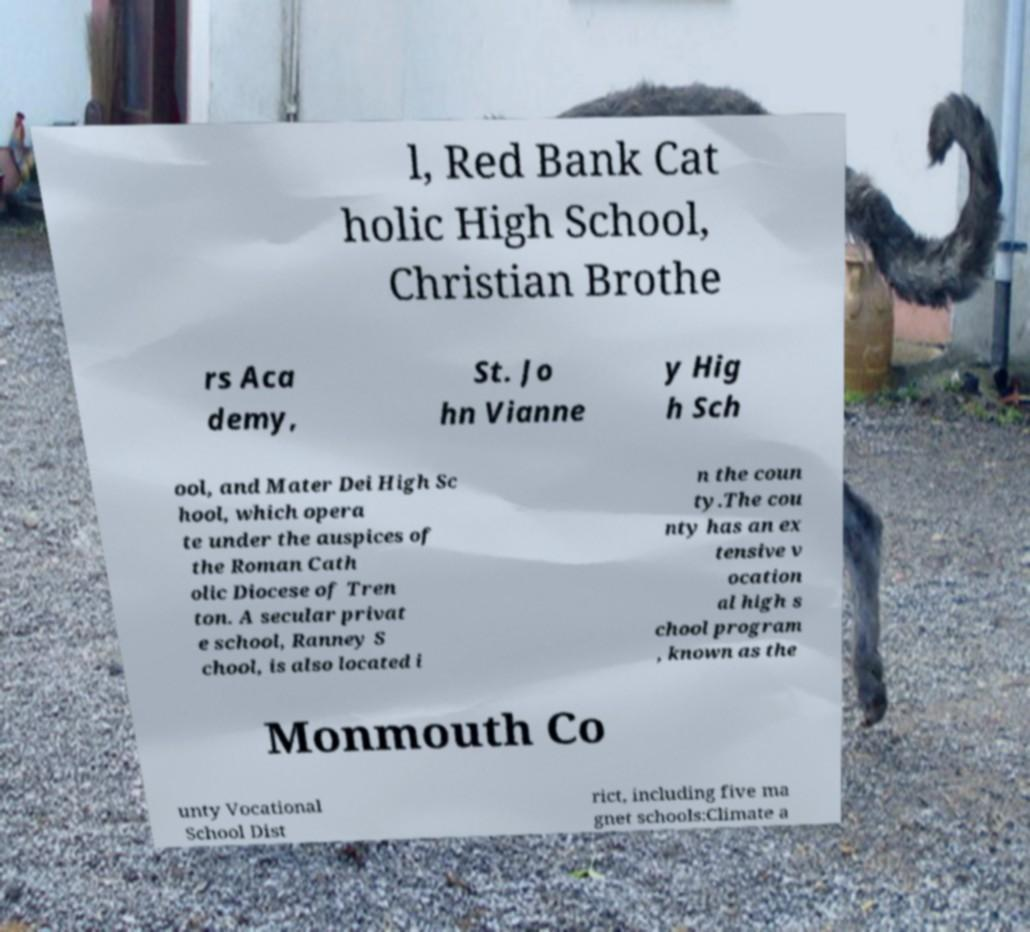Please read and relay the text visible in this image. What does it say? l, Red Bank Cat holic High School, Christian Brothe rs Aca demy, St. Jo hn Vianne y Hig h Sch ool, and Mater Dei High Sc hool, which opera te under the auspices of the Roman Cath olic Diocese of Tren ton. A secular privat e school, Ranney S chool, is also located i n the coun ty.The cou nty has an ex tensive v ocation al high s chool program , known as the Monmouth Co unty Vocational School Dist rict, including five ma gnet schools:Climate a 